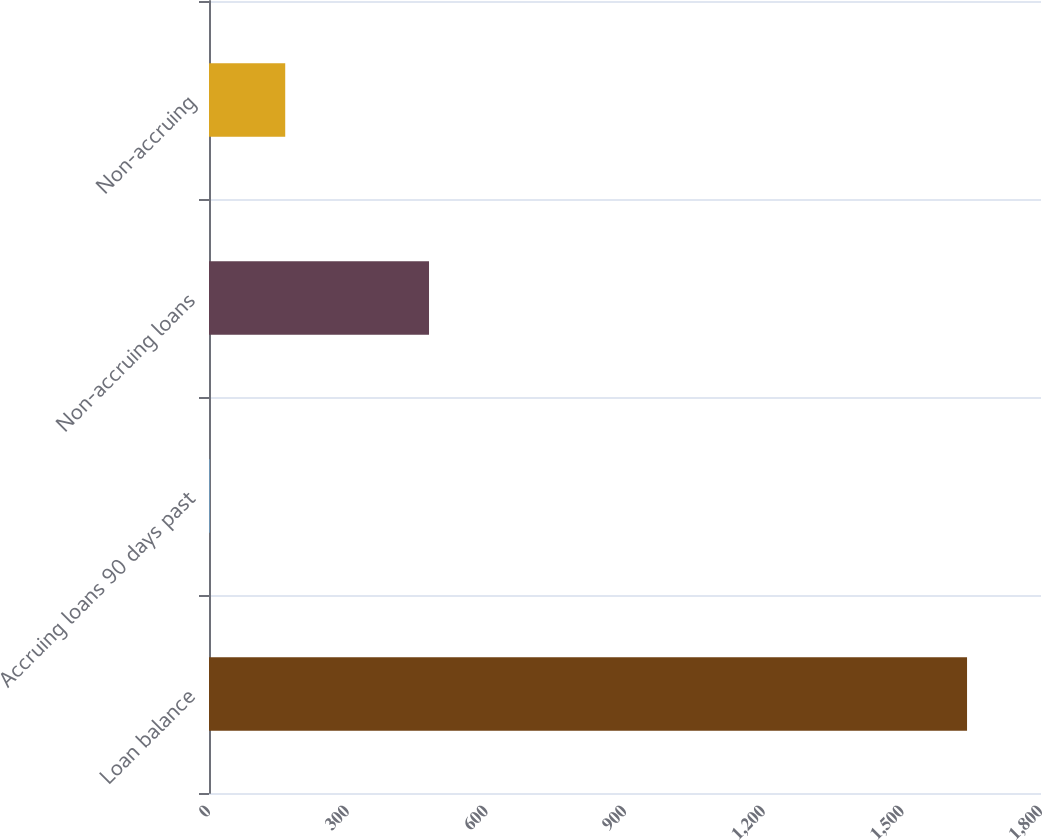Convert chart to OTSL. <chart><loc_0><loc_0><loc_500><loc_500><bar_chart><fcel>Loan balance<fcel>Accruing loans 90 days past<fcel>Non-accruing loans<fcel>Non-accruing<nl><fcel>1640<fcel>1<fcel>476<fcel>164.9<nl></chart> 